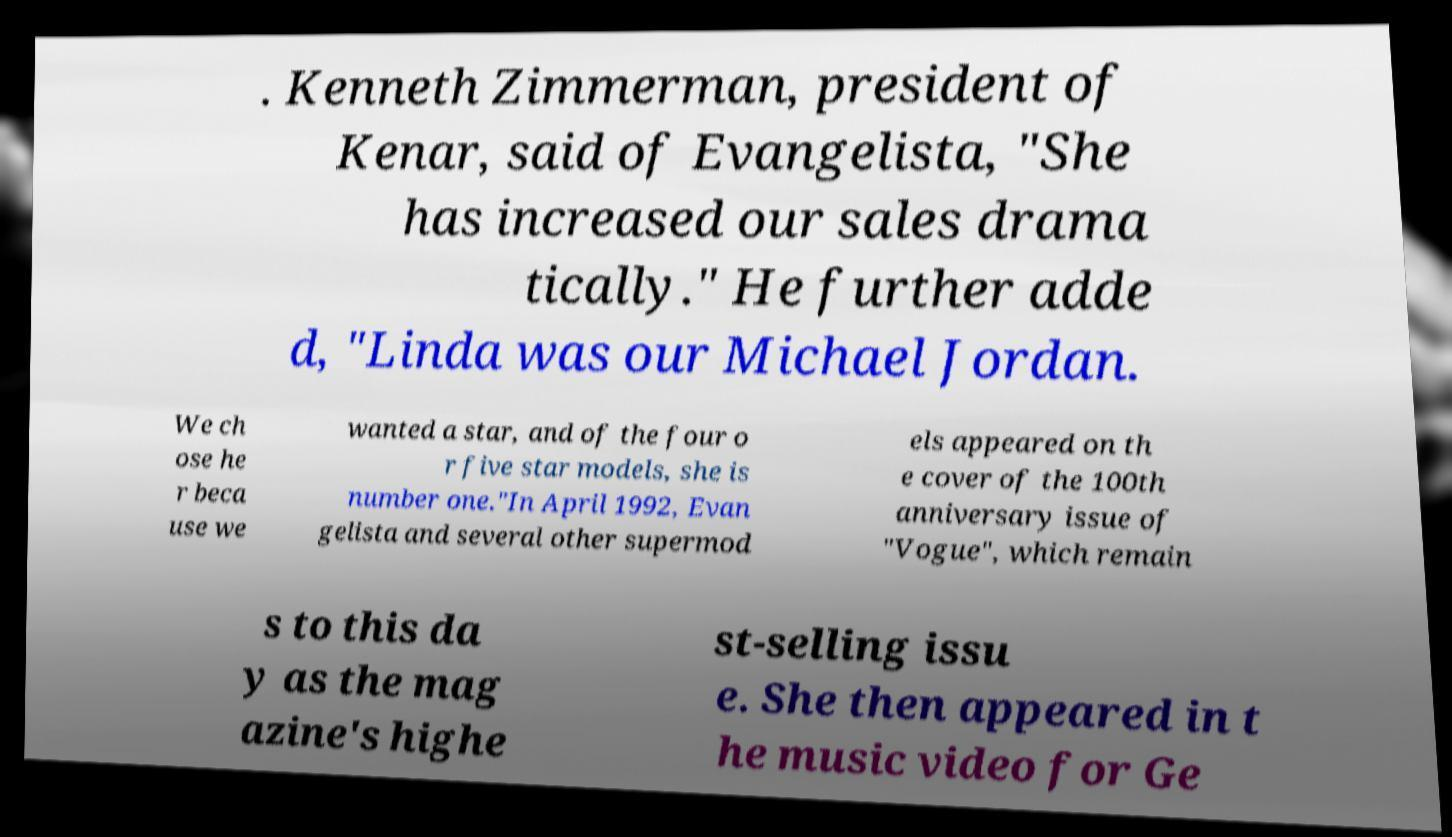Could you assist in decoding the text presented in this image and type it out clearly? . Kenneth Zimmerman, president of Kenar, said of Evangelista, "She has increased our sales drama tically." He further adde d, "Linda was our Michael Jordan. We ch ose he r beca use we wanted a star, and of the four o r five star models, she is number one."In April 1992, Evan gelista and several other supermod els appeared on th e cover of the 100th anniversary issue of "Vogue", which remain s to this da y as the mag azine's highe st-selling issu e. She then appeared in t he music video for Ge 